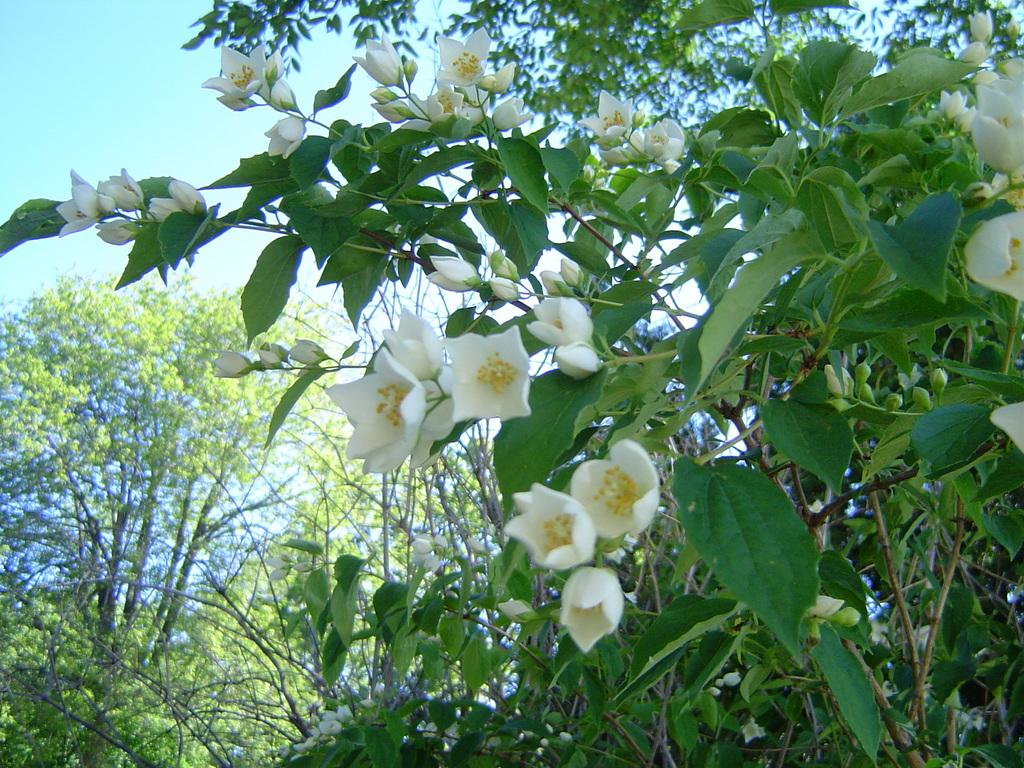What color are the flowers on the plant in the image? The flowers on the plant are white. What stage of growth are some of the flowers in? There are buds on the plant, indicating that some flowers are not yet fully bloomed. What can be seen in the background of the image? Trees are visible at the back of the image. What is visible at the top of the image? The sky is visible at the top of the image. What flavor of yarn is being used to knit the cannon in the image? There is no cannon or yarn present in the image. The image features a plant with white flowers and buds, along with trees and the sky in the background. 